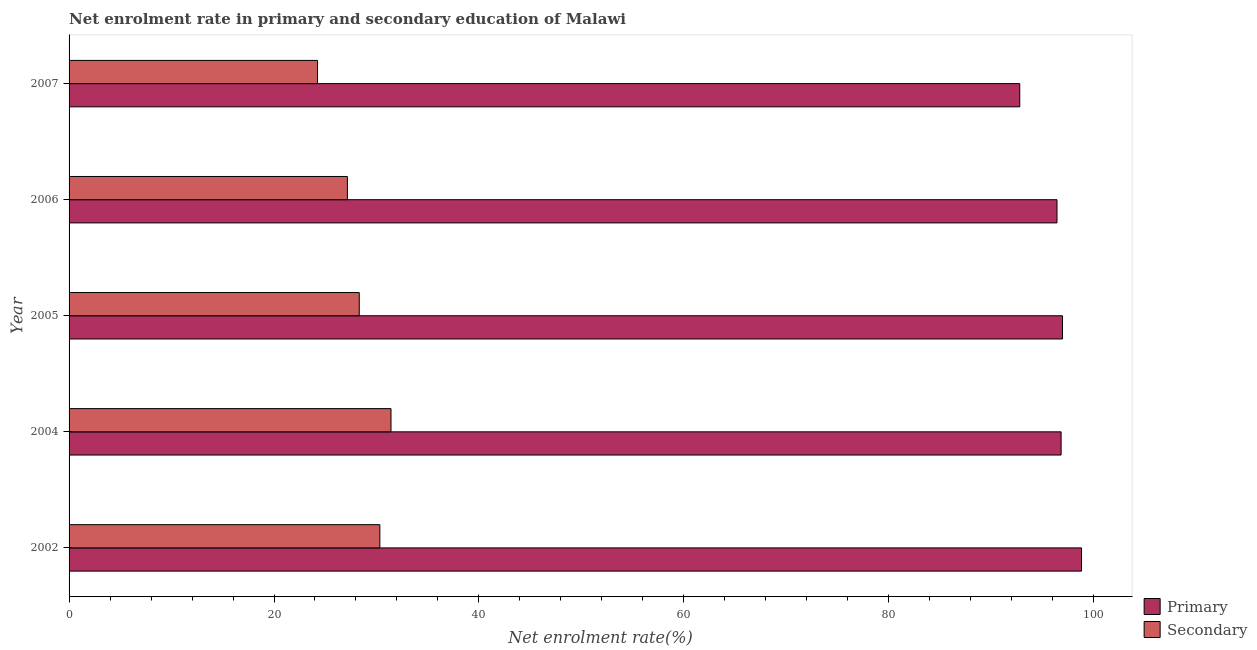How many different coloured bars are there?
Your answer should be compact. 2. How many groups of bars are there?
Provide a short and direct response. 5. What is the label of the 3rd group of bars from the top?
Offer a very short reply. 2005. What is the enrollment rate in secondary education in 2007?
Offer a terse response. 24.25. Across all years, what is the maximum enrollment rate in primary education?
Ensure brevity in your answer.  98.81. Across all years, what is the minimum enrollment rate in primary education?
Your answer should be compact. 92.78. In which year was the enrollment rate in secondary education minimum?
Provide a short and direct response. 2007. What is the total enrollment rate in secondary education in the graph?
Offer a very short reply. 141.48. What is the difference between the enrollment rate in secondary education in 2002 and that in 2004?
Offer a terse response. -1.09. What is the difference between the enrollment rate in primary education in 2004 and the enrollment rate in secondary education in 2002?
Your response must be concise. 66.49. What is the average enrollment rate in primary education per year?
Keep it short and to the point. 96.35. In the year 2004, what is the difference between the enrollment rate in secondary education and enrollment rate in primary education?
Provide a short and direct response. -65.4. What is the ratio of the enrollment rate in primary education in 2002 to that in 2005?
Your answer should be compact. 1.02. Is the enrollment rate in primary education in 2005 less than that in 2006?
Keep it short and to the point. No. Is the difference between the enrollment rate in secondary education in 2002 and 2007 greater than the difference between the enrollment rate in primary education in 2002 and 2007?
Ensure brevity in your answer.  Yes. What is the difference between the highest and the second highest enrollment rate in secondary education?
Provide a short and direct response. 1.09. What is the difference between the highest and the lowest enrollment rate in secondary education?
Your answer should be compact. 7.17. Is the sum of the enrollment rate in secondary education in 2002 and 2007 greater than the maximum enrollment rate in primary education across all years?
Offer a terse response. No. What does the 2nd bar from the top in 2002 represents?
Provide a short and direct response. Primary. What does the 2nd bar from the bottom in 2004 represents?
Provide a short and direct response. Secondary. How many bars are there?
Offer a terse response. 10. What is the difference between two consecutive major ticks on the X-axis?
Provide a short and direct response. 20. Does the graph contain any zero values?
Provide a short and direct response. No. How are the legend labels stacked?
Your response must be concise. Vertical. What is the title of the graph?
Offer a very short reply. Net enrolment rate in primary and secondary education of Malawi. Does "US$" appear as one of the legend labels in the graph?
Your response must be concise. No. What is the label or title of the X-axis?
Your response must be concise. Net enrolment rate(%). What is the label or title of the Y-axis?
Ensure brevity in your answer.  Year. What is the Net enrolment rate(%) of Primary in 2002?
Give a very brief answer. 98.81. What is the Net enrolment rate(%) in Secondary in 2002?
Keep it short and to the point. 30.33. What is the Net enrolment rate(%) of Primary in 2004?
Give a very brief answer. 96.82. What is the Net enrolment rate(%) of Secondary in 2004?
Your answer should be very brief. 31.42. What is the Net enrolment rate(%) in Primary in 2005?
Your response must be concise. 96.95. What is the Net enrolment rate(%) of Secondary in 2005?
Ensure brevity in your answer.  28.32. What is the Net enrolment rate(%) of Primary in 2006?
Your response must be concise. 96.42. What is the Net enrolment rate(%) in Secondary in 2006?
Offer a very short reply. 27.16. What is the Net enrolment rate(%) in Primary in 2007?
Give a very brief answer. 92.78. What is the Net enrolment rate(%) of Secondary in 2007?
Your answer should be compact. 24.25. Across all years, what is the maximum Net enrolment rate(%) in Primary?
Provide a succinct answer. 98.81. Across all years, what is the maximum Net enrolment rate(%) of Secondary?
Your response must be concise. 31.42. Across all years, what is the minimum Net enrolment rate(%) of Primary?
Provide a succinct answer. 92.78. Across all years, what is the minimum Net enrolment rate(%) in Secondary?
Offer a terse response. 24.25. What is the total Net enrolment rate(%) of Primary in the graph?
Keep it short and to the point. 481.77. What is the total Net enrolment rate(%) in Secondary in the graph?
Provide a succinct answer. 141.48. What is the difference between the Net enrolment rate(%) of Primary in 2002 and that in 2004?
Give a very brief answer. 1.99. What is the difference between the Net enrolment rate(%) of Secondary in 2002 and that in 2004?
Provide a short and direct response. -1.09. What is the difference between the Net enrolment rate(%) in Primary in 2002 and that in 2005?
Make the answer very short. 1.85. What is the difference between the Net enrolment rate(%) of Secondary in 2002 and that in 2005?
Your answer should be compact. 2.01. What is the difference between the Net enrolment rate(%) of Primary in 2002 and that in 2006?
Ensure brevity in your answer.  2.39. What is the difference between the Net enrolment rate(%) of Secondary in 2002 and that in 2006?
Provide a short and direct response. 3.17. What is the difference between the Net enrolment rate(%) of Primary in 2002 and that in 2007?
Your answer should be very brief. 6.03. What is the difference between the Net enrolment rate(%) in Secondary in 2002 and that in 2007?
Your response must be concise. 6.08. What is the difference between the Net enrolment rate(%) of Primary in 2004 and that in 2005?
Offer a very short reply. -0.14. What is the difference between the Net enrolment rate(%) in Secondary in 2004 and that in 2005?
Offer a terse response. 3.1. What is the difference between the Net enrolment rate(%) of Primary in 2004 and that in 2006?
Your answer should be compact. 0.4. What is the difference between the Net enrolment rate(%) of Secondary in 2004 and that in 2006?
Give a very brief answer. 4.25. What is the difference between the Net enrolment rate(%) in Primary in 2004 and that in 2007?
Make the answer very short. 4.04. What is the difference between the Net enrolment rate(%) in Secondary in 2004 and that in 2007?
Offer a terse response. 7.17. What is the difference between the Net enrolment rate(%) of Primary in 2005 and that in 2006?
Your answer should be compact. 0.54. What is the difference between the Net enrolment rate(%) in Secondary in 2005 and that in 2006?
Provide a short and direct response. 1.16. What is the difference between the Net enrolment rate(%) in Primary in 2005 and that in 2007?
Provide a succinct answer. 4.17. What is the difference between the Net enrolment rate(%) of Secondary in 2005 and that in 2007?
Keep it short and to the point. 4.07. What is the difference between the Net enrolment rate(%) of Primary in 2006 and that in 2007?
Make the answer very short. 3.64. What is the difference between the Net enrolment rate(%) of Secondary in 2006 and that in 2007?
Offer a terse response. 2.92. What is the difference between the Net enrolment rate(%) of Primary in 2002 and the Net enrolment rate(%) of Secondary in 2004?
Your response must be concise. 67.39. What is the difference between the Net enrolment rate(%) in Primary in 2002 and the Net enrolment rate(%) in Secondary in 2005?
Your answer should be compact. 70.49. What is the difference between the Net enrolment rate(%) in Primary in 2002 and the Net enrolment rate(%) in Secondary in 2006?
Give a very brief answer. 71.64. What is the difference between the Net enrolment rate(%) of Primary in 2002 and the Net enrolment rate(%) of Secondary in 2007?
Keep it short and to the point. 74.56. What is the difference between the Net enrolment rate(%) in Primary in 2004 and the Net enrolment rate(%) in Secondary in 2005?
Offer a very short reply. 68.5. What is the difference between the Net enrolment rate(%) of Primary in 2004 and the Net enrolment rate(%) of Secondary in 2006?
Your answer should be very brief. 69.65. What is the difference between the Net enrolment rate(%) of Primary in 2004 and the Net enrolment rate(%) of Secondary in 2007?
Offer a very short reply. 72.57. What is the difference between the Net enrolment rate(%) of Primary in 2005 and the Net enrolment rate(%) of Secondary in 2006?
Keep it short and to the point. 69.79. What is the difference between the Net enrolment rate(%) in Primary in 2005 and the Net enrolment rate(%) in Secondary in 2007?
Your answer should be compact. 72.7. What is the difference between the Net enrolment rate(%) of Primary in 2006 and the Net enrolment rate(%) of Secondary in 2007?
Give a very brief answer. 72.17. What is the average Net enrolment rate(%) of Primary per year?
Your answer should be compact. 96.35. What is the average Net enrolment rate(%) of Secondary per year?
Your answer should be very brief. 28.3. In the year 2002, what is the difference between the Net enrolment rate(%) of Primary and Net enrolment rate(%) of Secondary?
Ensure brevity in your answer.  68.48. In the year 2004, what is the difference between the Net enrolment rate(%) of Primary and Net enrolment rate(%) of Secondary?
Offer a very short reply. 65.4. In the year 2005, what is the difference between the Net enrolment rate(%) of Primary and Net enrolment rate(%) of Secondary?
Provide a short and direct response. 68.63. In the year 2006, what is the difference between the Net enrolment rate(%) in Primary and Net enrolment rate(%) in Secondary?
Keep it short and to the point. 69.25. In the year 2007, what is the difference between the Net enrolment rate(%) in Primary and Net enrolment rate(%) in Secondary?
Make the answer very short. 68.53. What is the ratio of the Net enrolment rate(%) in Primary in 2002 to that in 2004?
Offer a terse response. 1.02. What is the ratio of the Net enrolment rate(%) of Secondary in 2002 to that in 2004?
Your answer should be very brief. 0.97. What is the ratio of the Net enrolment rate(%) of Primary in 2002 to that in 2005?
Your answer should be compact. 1.02. What is the ratio of the Net enrolment rate(%) of Secondary in 2002 to that in 2005?
Your answer should be compact. 1.07. What is the ratio of the Net enrolment rate(%) of Primary in 2002 to that in 2006?
Keep it short and to the point. 1.02. What is the ratio of the Net enrolment rate(%) in Secondary in 2002 to that in 2006?
Your answer should be compact. 1.12. What is the ratio of the Net enrolment rate(%) of Primary in 2002 to that in 2007?
Offer a terse response. 1.06. What is the ratio of the Net enrolment rate(%) of Secondary in 2002 to that in 2007?
Make the answer very short. 1.25. What is the ratio of the Net enrolment rate(%) in Secondary in 2004 to that in 2005?
Ensure brevity in your answer.  1.11. What is the ratio of the Net enrolment rate(%) of Secondary in 2004 to that in 2006?
Provide a succinct answer. 1.16. What is the ratio of the Net enrolment rate(%) of Primary in 2004 to that in 2007?
Make the answer very short. 1.04. What is the ratio of the Net enrolment rate(%) in Secondary in 2004 to that in 2007?
Your answer should be compact. 1.3. What is the ratio of the Net enrolment rate(%) of Primary in 2005 to that in 2006?
Make the answer very short. 1.01. What is the ratio of the Net enrolment rate(%) in Secondary in 2005 to that in 2006?
Your answer should be compact. 1.04. What is the ratio of the Net enrolment rate(%) of Primary in 2005 to that in 2007?
Your answer should be very brief. 1.04. What is the ratio of the Net enrolment rate(%) in Secondary in 2005 to that in 2007?
Keep it short and to the point. 1.17. What is the ratio of the Net enrolment rate(%) in Primary in 2006 to that in 2007?
Provide a succinct answer. 1.04. What is the ratio of the Net enrolment rate(%) of Secondary in 2006 to that in 2007?
Make the answer very short. 1.12. What is the difference between the highest and the second highest Net enrolment rate(%) of Primary?
Make the answer very short. 1.85. What is the difference between the highest and the second highest Net enrolment rate(%) of Secondary?
Your answer should be very brief. 1.09. What is the difference between the highest and the lowest Net enrolment rate(%) in Primary?
Your answer should be compact. 6.03. What is the difference between the highest and the lowest Net enrolment rate(%) in Secondary?
Keep it short and to the point. 7.17. 